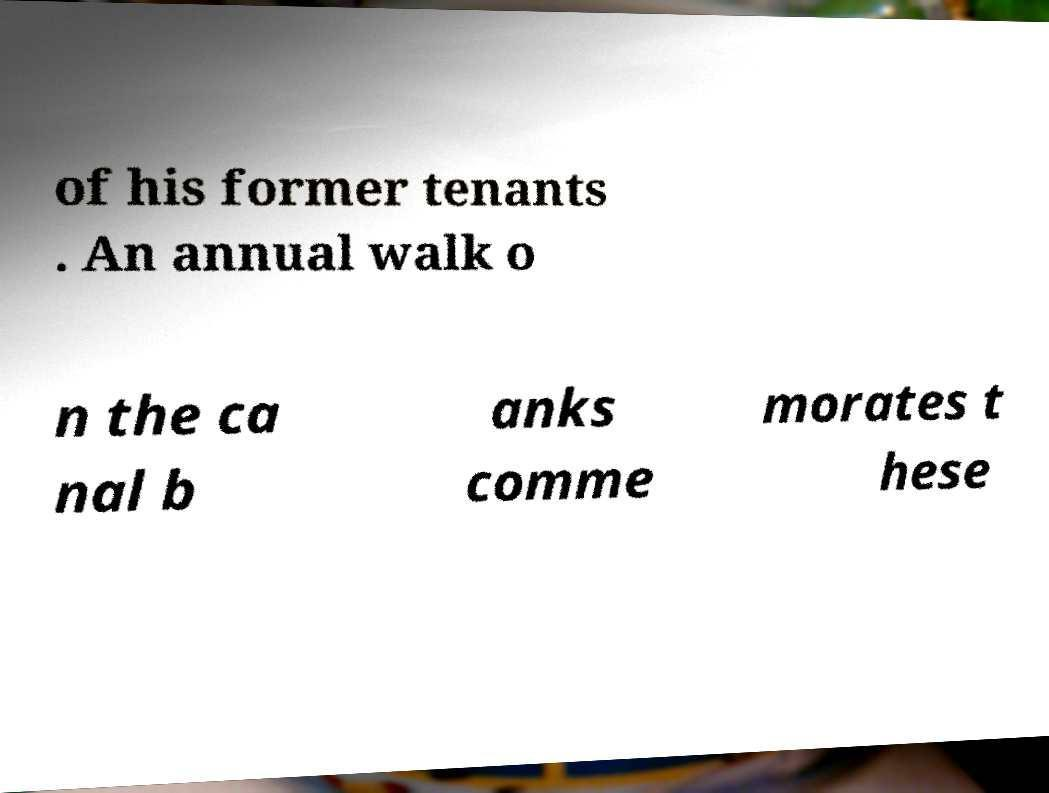For documentation purposes, I need the text within this image transcribed. Could you provide that? of his former tenants . An annual walk o n the ca nal b anks comme morates t hese 